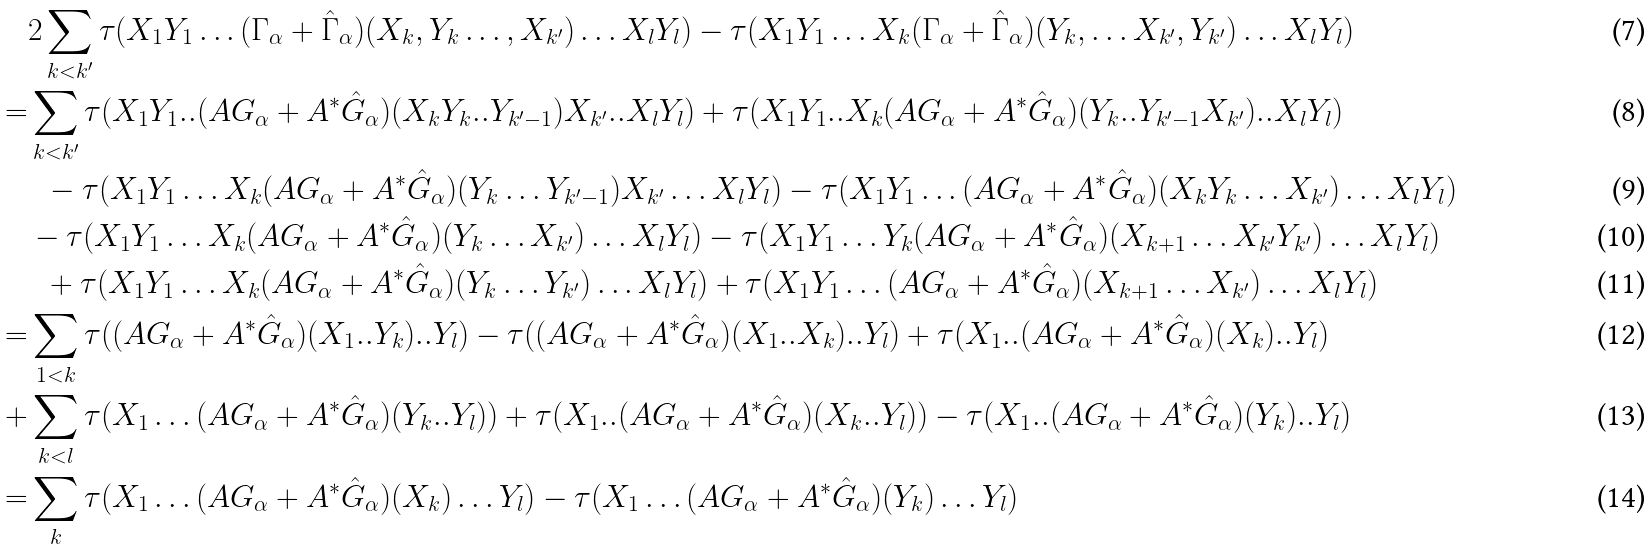Convert formula to latex. <formula><loc_0><loc_0><loc_500><loc_500>& 2 \sum _ { k < k ^ { \prime } } \tau ( X _ { 1 } Y _ { 1 } \dots ( \Gamma _ { \alpha } + \hat { \Gamma } _ { \alpha } ) ( X _ { k } , Y _ { k } \dots , X _ { k ^ { \prime } } ) \dots X _ { l } Y _ { l } ) - \tau ( X _ { 1 } Y _ { 1 } \dots X _ { k } ( \Gamma _ { \alpha } + \hat { \Gamma } _ { \alpha } ) ( Y _ { k } , \dots X _ { k ^ { \prime } } , Y _ { k ^ { \prime } } ) \dots X _ { l } Y _ { l } ) \\ = & \sum _ { k < k ^ { \prime } } \tau ( X _ { 1 } Y _ { 1 } . . ( A G _ { \alpha } + A ^ { * } \hat { G } _ { \alpha } ) ( X _ { k } Y _ { k } . . Y _ { k ^ { \prime } - 1 } ) X _ { k ^ { \prime } } . . X _ { l } Y _ { l } ) + \tau ( X _ { 1 } Y _ { 1 } . . X _ { k } ( A G _ { \alpha } + A ^ { * } \hat { G } _ { \alpha } ) ( Y _ { k } . . Y _ { k ^ { \prime } - 1 } X _ { k ^ { \prime } } ) . . X _ { l } Y _ { l } ) \\ & \ \ - \tau ( X _ { 1 } Y _ { 1 } \dots X _ { k } ( A G _ { \alpha } + A ^ { * } \hat { G } _ { \alpha } ) ( Y _ { k } \dots Y _ { k ^ { \prime } - 1 } ) X _ { k ^ { \prime } } \dots X _ { l } Y _ { l } ) - \tau ( X _ { 1 } Y _ { 1 } \dots ( A G _ { \alpha } + A ^ { * } \hat { G } _ { \alpha } ) ( X _ { k } Y _ { k } \dots X _ { k ^ { \prime } } ) \dots X _ { l } Y _ { l } ) \\ & - \tau ( X _ { 1 } Y _ { 1 } \dots X _ { k } ( A G _ { \alpha } + A ^ { * } \hat { G } _ { \alpha } ) ( Y _ { k } \dots X _ { k ^ { \prime } } ) \dots X _ { l } Y _ { l } ) - \tau ( X _ { 1 } Y _ { 1 } \dots Y _ { k } ( A G _ { \alpha } + A ^ { * } \hat { G } _ { \alpha } ) ( X _ { k + 1 } \dots X _ { k ^ { \prime } } Y _ { k ^ { \prime } } ) \dots X _ { l } Y _ { l } ) \\ & \ \ + \tau ( X _ { 1 } Y _ { 1 } \dots X _ { k } ( A G _ { \alpha } + A ^ { * } \hat { G } _ { \alpha } ) ( Y _ { k } \dots Y _ { k ^ { \prime } } ) \dots X _ { l } Y _ { l } ) + \tau ( X _ { 1 } Y _ { 1 } \dots ( A G _ { \alpha } + A ^ { * } \hat { G } _ { \alpha } ) ( X _ { k + 1 } \dots X _ { k ^ { \prime } } ) \dots X _ { l } Y _ { l } ) \\ = & \sum _ { 1 < k } \tau ( ( A G _ { \alpha } + A ^ { * } \hat { G } _ { \alpha } ) ( X _ { 1 } . . Y _ { k } ) . . Y _ { l } ) - \tau ( ( A G _ { \alpha } + A ^ { * } \hat { G } _ { \alpha } ) ( X _ { 1 } . . X _ { k } ) . . Y _ { l } ) + \tau ( X _ { 1 } . . ( A G _ { \alpha } + A ^ { * } \hat { G } _ { \alpha } ) ( X _ { k } ) . . Y _ { l } ) \\ + & \sum _ { k < l } \tau ( X _ { 1 } \dots ( A G _ { \alpha } + A ^ { * } \hat { G } _ { \alpha } ) ( Y _ { k } . . Y _ { l } ) ) + \tau ( X _ { 1 } . . ( A G _ { \alpha } + A ^ { * } \hat { G } _ { \alpha } ) ( X _ { k } . . Y _ { l } ) ) - \tau ( X _ { 1 } . . ( A G _ { \alpha } + A ^ { * } \hat { G } _ { \alpha } ) ( Y _ { k } ) . . Y _ { l } ) \\ = & \sum _ { k } \tau ( X _ { 1 } \dots ( A G _ { \alpha } + A ^ { * } \hat { G } _ { \alpha } ) ( X _ { k } ) \dots Y _ { l } ) - \tau ( X _ { 1 } \dots ( A G _ { \alpha } + A ^ { * } \hat { G } _ { \alpha } ) ( Y _ { k } ) \dots Y _ { l } )</formula> 